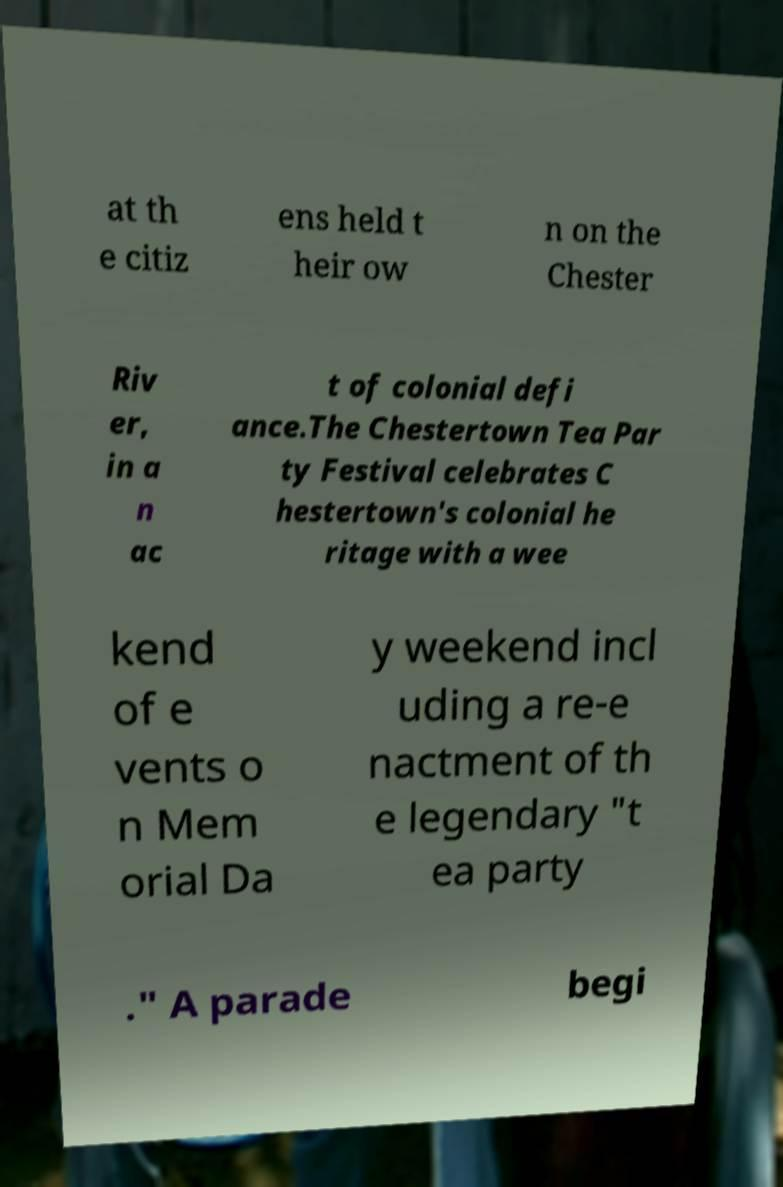For documentation purposes, I need the text within this image transcribed. Could you provide that? at th e citiz ens held t heir ow n on the Chester Riv er, in a n ac t of colonial defi ance.The Chestertown Tea Par ty Festival celebrates C hestertown's colonial he ritage with a wee kend of e vents o n Mem orial Da y weekend incl uding a re-e nactment of th e legendary "t ea party ." A parade begi 